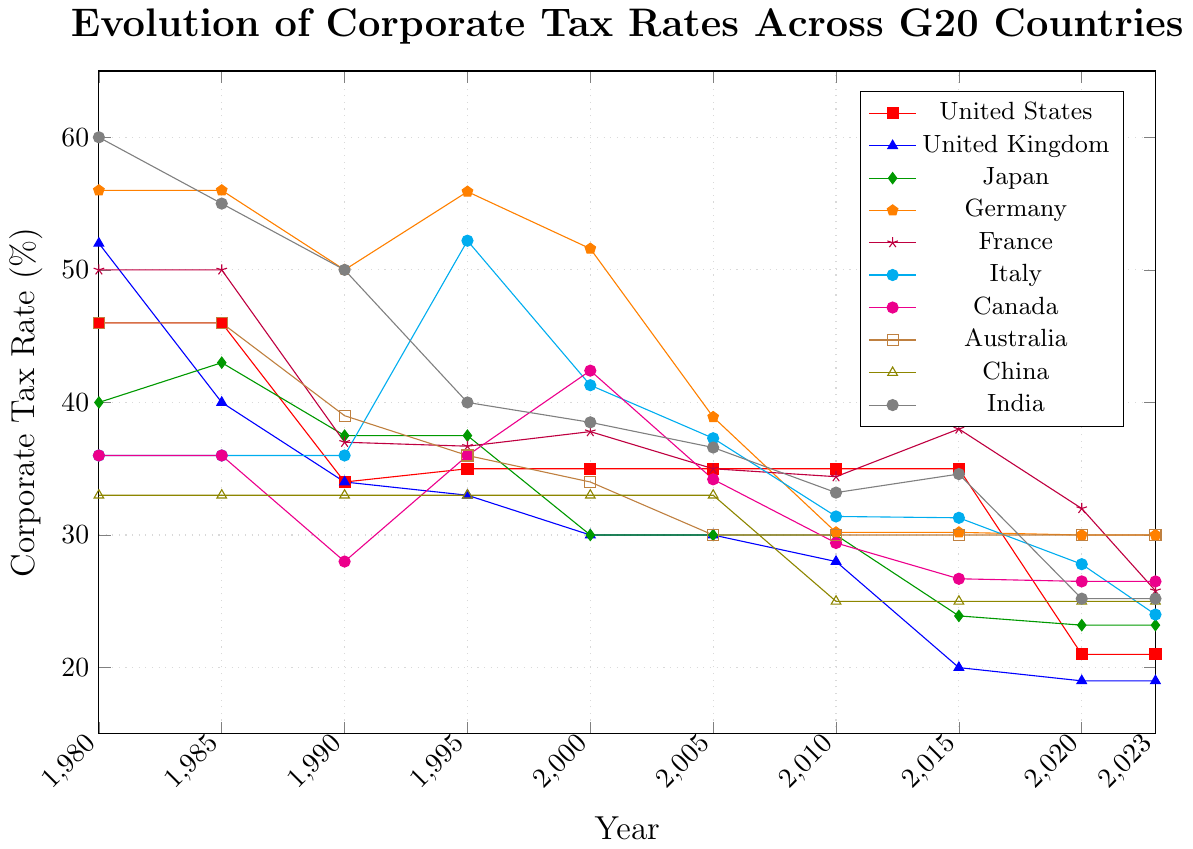What is the corporate tax rate for Germany in 2020? To find the corporate tax rate for Germany in 2020, look for the line representing Germany (orange color with pentagon markers) and identify the value at the year 2020 on the x-axis.
Answer: 30% Which country had the highest corporate tax rate in 1980? To determine which country had the highest corporate tax rate in 1980, locate the data points for all countries in that year and compare their heights. The highest value will indicate the country.
Answer: India What was the average corporate tax rate for Australia from 1980 to 2023? To find the average, sum all the corporate tax rates of Australia from 1980 to 2023 and divide by the number of years with data points. (46 + 46 + 39 + 36 + 34 + 30 + 30 + 30 + 30 + 30) / 10 = 35.1
Answer: 35.1% Which country had a lower corporate tax rate in 1980, the United Kingdom or France? Compare the tax rates of the United Kingdom (52%) and France (50%) in 1980. The line representing each country will help determine the values.
Answer: France What is the most significant drop in corporate tax rate for the United States, and in which period did it occur? Look at the United States' line and identify the steepest decline. The most significant drop is from 2015 (35%) to 2020 (21%). The drop is 35% - 21% = 14%.
Answer: 2015 to 2020, 14% By how much did India's corporate tax rate change from 1980 to 2023? Subtract the corporate tax rate of India in 2023 from its rate in 1980, 60% - 25.2% = 34.8%.
Answer: 34.8% Which two countries had the same corporate tax rate in 2005? Look at the data points for each country in 2005 and identify any matches. Australia and Australia, both had a rate of 30%.
Answer: Australia and Japan Estimate the median corporate tax rate for all countries in 2010. List out all the corporate tax rates in 2010 (35, 28, 30, 30.2, 34.4, 31.4, 29.4, 30, 25, 33.2) and find the median value. Sorting the values: (25, 28, 29.4, 30, 30, 30, 30.2, 31.4, 33.2, 34.4), the median value is (30 + 30.2)/ 2 = 30.1
Answer: 30.1% Did any country's corporate tax rate remain constant from 1980 to 2023? Examine each country's line to see if any line is perfectly horizontal throughout the entire period.
Answer: No 